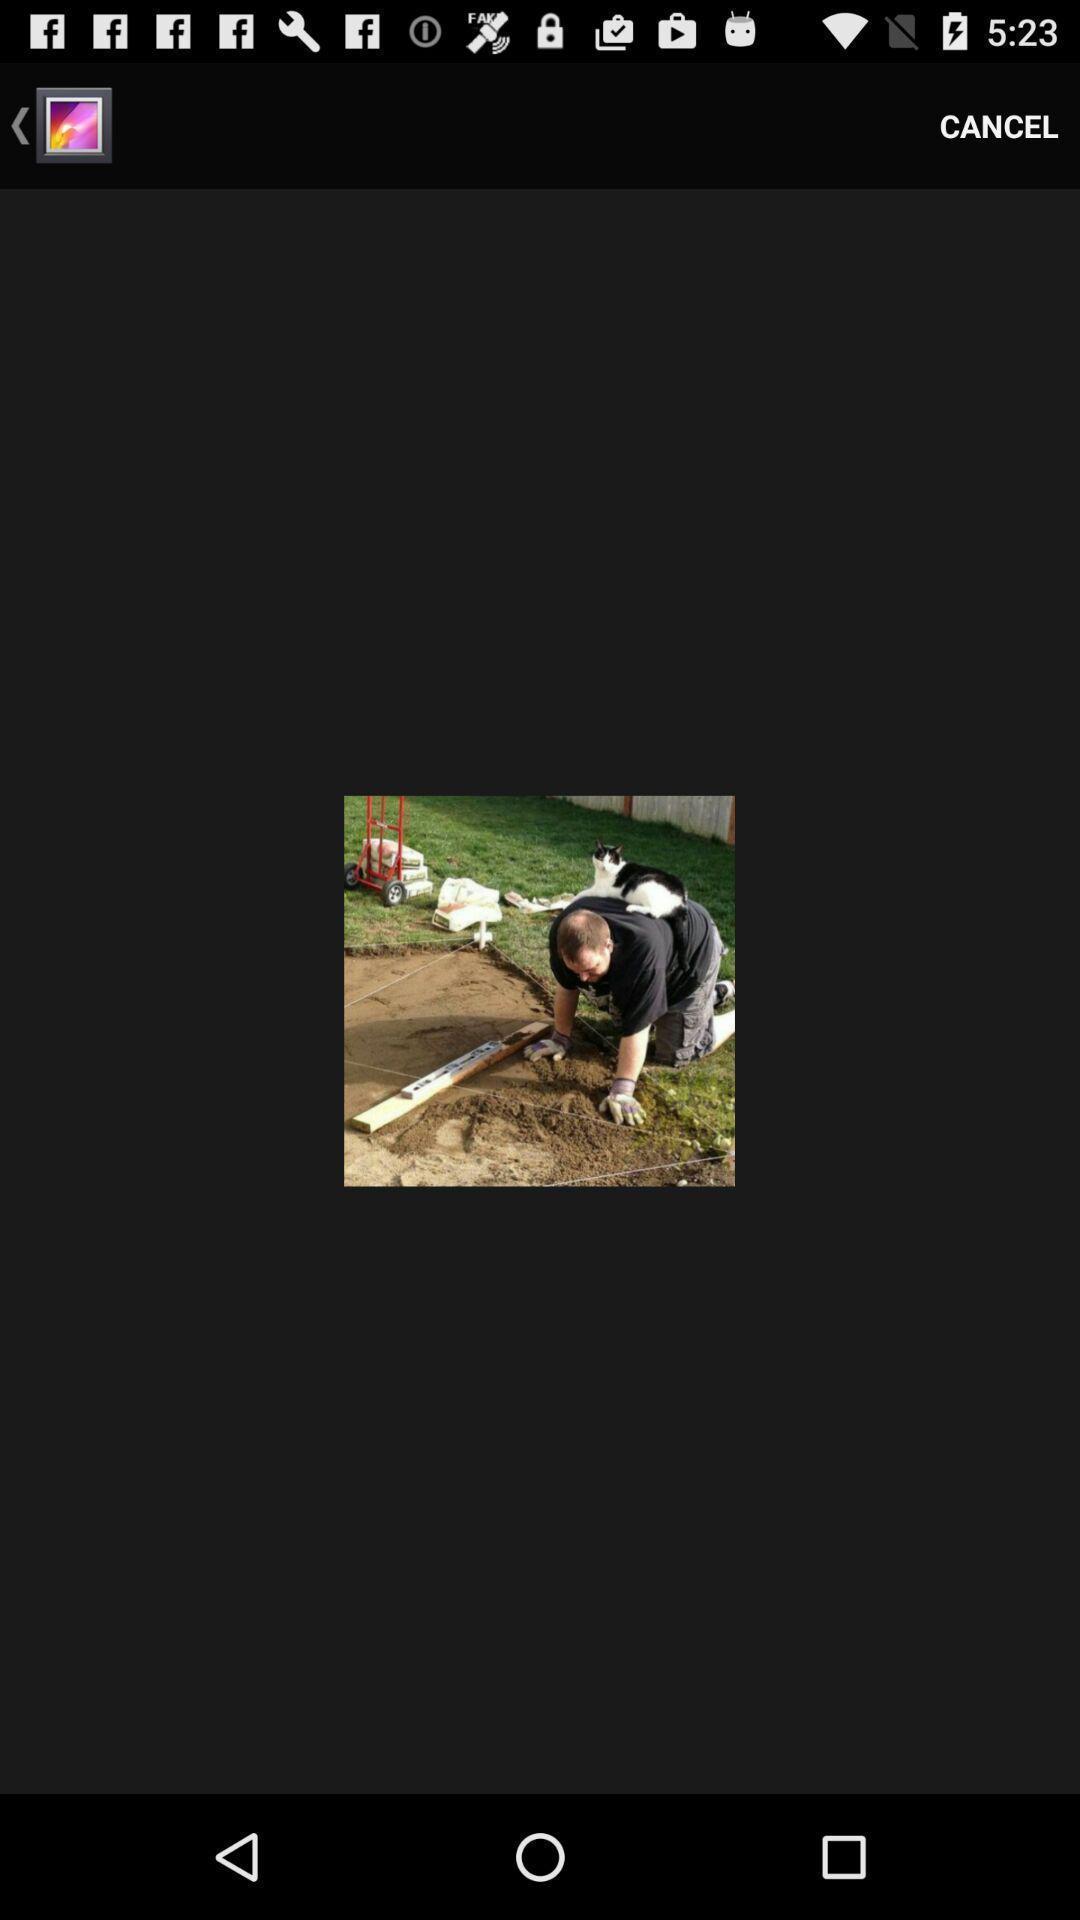Give me a narrative description of this picture. Screen display image in a photo editing app. 